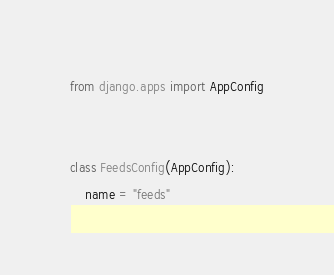Convert code to text. <code><loc_0><loc_0><loc_500><loc_500><_Python_>from django.apps import AppConfig


class FeedsConfig(AppConfig):
    name = "feeds"
</code> 